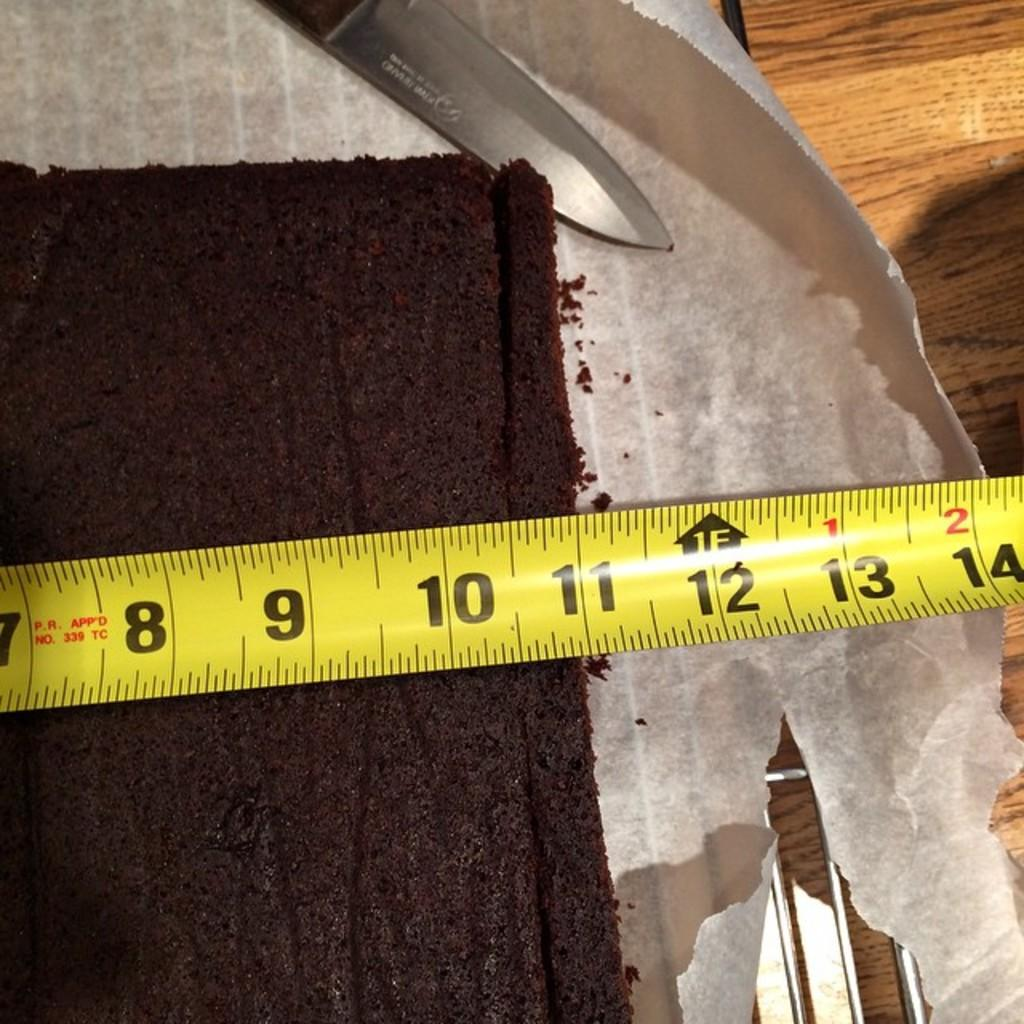<image>
Render a clear and concise summary of the photo. A yellow measuring tape is measuring the cake at 11 inches 